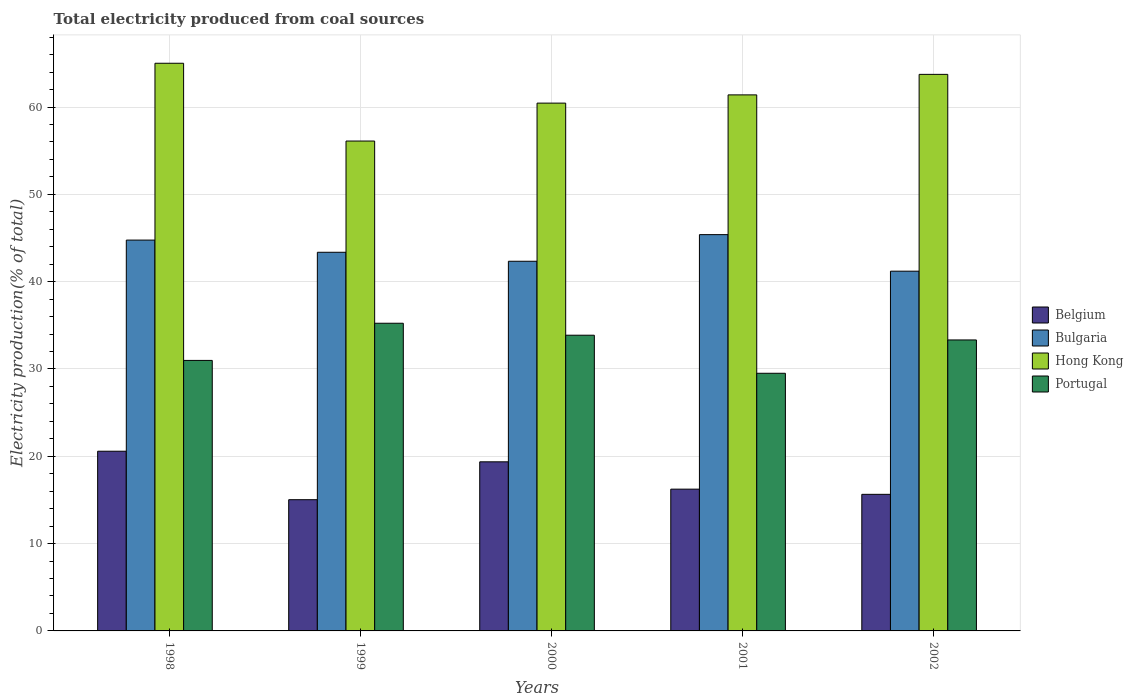How many different coloured bars are there?
Make the answer very short. 4. Are the number of bars per tick equal to the number of legend labels?
Offer a terse response. Yes. Are the number of bars on each tick of the X-axis equal?
Offer a very short reply. Yes. How many bars are there on the 4th tick from the left?
Your response must be concise. 4. In how many cases, is the number of bars for a given year not equal to the number of legend labels?
Keep it short and to the point. 0. What is the total electricity produced in Hong Kong in 1999?
Your answer should be compact. 56.1. Across all years, what is the maximum total electricity produced in Bulgaria?
Keep it short and to the point. 45.38. Across all years, what is the minimum total electricity produced in Portugal?
Offer a very short reply. 29.51. In which year was the total electricity produced in Portugal minimum?
Give a very brief answer. 2001. What is the total total electricity produced in Bulgaria in the graph?
Give a very brief answer. 217.04. What is the difference between the total electricity produced in Portugal in 1999 and that in 2002?
Ensure brevity in your answer.  1.91. What is the difference between the total electricity produced in Belgium in 2000 and the total electricity produced in Hong Kong in 2002?
Your response must be concise. -44.37. What is the average total electricity produced in Portugal per year?
Ensure brevity in your answer.  32.58. In the year 2002, what is the difference between the total electricity produced in Portugal and total electricity produced in Bulgaria?
Ensure brevity in your answer.  -7.88. In how many years, is the total electricity produced in Portugal greater than 10 %?
Offer a very short reply. 5. What is the ratio of the total electricity produced in Belgium in 2000 to that in 2001?
Your answer should be compact. 1.19. Is the difference between the total electricity produced in Portugal in 1998 and 2002 greater than the difference between the total electricity produced in Bulgaria in 1998 and 2002?
Provide a succinct answer. No. What is the difference between the highest and the second highest total electricity produced in Bulgaria?
Your answer should be very brief. 0.62. What is the difference between the highest and the lowest total electricity produced in Belgium?
Your answer should be very brief. 5.55. In how many years, is the total electricity produced in Portugal greater than the average total electricity produced in Portugal taken over all years?
Your answer should be compact. 3. Is the sum of the total electricity produced in Hong Kong in 1998 and 2000 greater than the maximum total electricity produced in Bulgaria across all years?
Your answer should be compact. Yes. What does the 1st bar from the left in 1999 represents?
Your answer should be compact. Belgium. What does the 1st bar from the right in 2002 represents?
Offer a terse response. Portugal. How many years are there in the graph?
Offer a very short reply. 5. What is the difference between two consecutive major ticks on the Y-axis?
Offer a terse response. 10. Are the values on the major ticks of Y-axis written in scientific E-notation?
Provide a succinct answer. No. Does the graph contain any zero values?
Ensure brevity in your answer.  No. What is the title of the graph?
Keep it short and to the point. Total electricity produced from coal sources. What is the label or title of the X-axis?
Make the answer very short. Years. What is the label or title of the Y-axis?
Offer a terse response. Electricity production(% of total). What is the Electricity production(% of total) of Belgium in 1998?
Give a very brief answer. 20.58. What is the Electricity production(% of total) in Bulgaria in 1998?
Offer a very short reply. 44.76. What is the Electricity production(% of total) in Hong Kong in 1998?
Offer a terse response. 65.01. What is the Electricity production(% of total) in Portugal in 1998?
Give a very brief answer. 30.98. What is the Electricity production(% of total) in Belgium in 1999?
Ensure brevity in your answer.  15.03. What is the Electricity production(% of total) of Bulgaria in 1999?
Offer a very short reply. 43.36. What is the Electricity production(% of total) of Hong Kong in 1999?
Provide a succinct answer. 56.1. What is the Electricity production(% of total) in Portugal in 1999?
Give a very brief answer. 35.24. What is the Electricity production(% of total) of Belgium in 2000?
Make the answer very short. 19.37. What is the Electricity production(% of total) of Bulgaria in 2000?
Keep it short and to the point. 42.33. What is the Electricity production(% of total) in Hong Kong in 2000?
Offer a terse response. 60.44. What is the Electricity production(% of total) of Portugal in 2000?
Provide a short and direct response. 33.87. What is the Electricity production(% of total) of Belgium in 2001?
Provide a succinct answer. 16.24. What is the Electricity production(% of total) in Bulgaria in 2001?
Give a very brief answer. 45.38. What is the Electricity production(% of total) in Hong Kong in 2001?
Make the answer very short. 61.39. What is the Electricity production(% of total) of Portugal in 2001?
Keep it short and to the point. 29.51. What is the Electricity production(% of total) in Belgium in 2002?
Offer a very short reply. 15.64. What is the Electricity production(% of total) in Bulgaria in 2002?
Offer a very short reply. 41.2. What is the Electricity production(% of total) of Hong Kong in 2002?
Your answer should be compact. 63.74. What is the Electricity production(% of total) of Portugal in 2002?
Provide a short and direct response. 33.32. Across all years, what is the maximum Electricity production(% of total) of Belgium?
Offer a terse response. 20.58. Across all years, what is the maximum Electricity production(% of total) of Bulgaria?
Provide a short and direct response. 45.38. Across all years, what is the maximum Electricity production(% of total) of Hong Kong?
Make the answer very short. 65.01. Across all years, what is the maximum Electricity production(% of total) in Portugal?
Offer a terse response. 35.24. Across all years, what is the minimum Electricity production(% of total) of Belgium?
Offer a very short reply. 15.03. Across all years, what is the minimum Electricity production(% of total) in Bulgaria?
Provide a succinct answer. 41.2. Across all years, what is the minimum Electricity production(% of total) of Hong Kong?
Provide a short and direct response. 56.1. Across all years, what is the minimum Electricity production(% of total) in Portugal?
Your response must be concise. 29.51. What is the total Electricity production(% of total) of Belgium in the graph?
Provide a short and direct response. 86.85. What is the total Electricity production(% of total) in Bulgaria in the graph?
Your answer should be compact. 217.04. What is the total Electricity production(% of total) in Hong Kong in the graph?
Make the answer very short. 306.68. What is the total Electricity production(% of total) of Portugal in the graph?
Ensure brevity in your answer.  162.91. What is the difference between the Electricity production(% of total) in Belgium in 1998 and that in 1999?
Give a very brief answer. 5.55. What is the difference between the Electricity production(% of total) in Bulgaria in 1998 and that in 1999?
Make the answer very short. 1.4. What is the difference between the Electricity production(% of total) in Hong Kong in 1998 and that in 1999?
Your response must be concise. 8.91. What is the difference between the Electricity production(% of total) in Portugal in 1998 and that in 1999?
Keep it short and to the point. -4.26. What is the difference between the Electricity production(% of total) in Belgium in 1998 and that in 2000?
Your answer should be very brief. 1.21. What is the difference between the Electricity production(% of total) of Bulgaria in 1998 and that in 2000?
Your answer should be compact. 2.42. What is the difference between the Electricity production(% of total) in Hong Kong in 1998 and that in 2000?
Offer a very short reply. 4.56. What is the difference between the Electricity production(% of total) in Portugal in 1998 and that in 2000?
Offer a very short reply. -2.89. What is the difference between the Electricity production(% of total) of Belgium in 1998 and that in 2001?
Offer a terse response. 4.34. What is the difference between the Electricity production(% of total) of Bulgaria in 1998 and that in 2001?
Your response must be concise. -0.62. What is the difference between the Electricity production(% of total) in Hong Kong in 1998 and that in 2001?
Keep it short and to the point. 3.62. What is the difference between the Electricity production(% of total) in Portugal in 1998 and that in 2001?
Offer a very short reply. 1.47. What is the difference between the Electricity production(% of total) of Belgium in 1998 and that in 2002?
Keep it short and to the point. 4.94. What is the difference between the Electricity production(% of total) of Bulgaria in 1998 and that in 2002?
Your answer should be compact. 3.56. What is the difference between the Electricity production(% of total) of Hong Kong in 1998 and that in 2002?
Your answer should be very brief. 1.27. What is the difference between the Electricity production(% of total) of Portugal in 1998 and that in 2002?
Keep it short and to the point. -2.34. What is the difference between the Electricity production(% of total) in Belgium in 1999 and that in 2000?
Keep it short and to the point. -4.34. What is the difference between the Electricity production(% of total) in Bulgaria in 1999 and that in 2000?
Provide a succinct answer. 1.03. What is the difference between the Electricity production(% of total) in Hong Kong in 1999 and that in 2000?
Your answer should be compact. -4.34. What is the difference between the Electricity production(% of total) of Portugal in 1999 and that in 2000?
Ensure brevity in your answer.  1.37. What is the difference between the Electricity production(% of total) in Belgium in 1999 and that in 2001?
Offer a terse response. -1.21. What is the difference between the Electricity production(% of total) in Bulgaria in 1999 and that in 2001?
Offer a very short reply. -2.02. What is the difference between the Electricity production(% of total) of Hong Kong in 1999 and that in 2001?
Offer a very short reply. -5.28. What is the difference between the Electricity production(% of total) of Portugal in 1999 and that in 2001?
Provide a short and direct response. 5.73. What is the difference between the Electricity production(% of total) in Belgium in 1999 and that in 2002?
Keep it short and to the point. -0.61. What is the difference between the Electricity production(% of total) in Bulgaria in 1999 and that in 2002?
Your answer should be very brief. 2.16. What is the difference between the Electricity production(% of total) in Hong Kong in 1999 and that in 2002?
Provide a succinct answer. -7.64. What is the difference between the Electricity production(% of total) in Portugal in 1999 and that in 2002?
Keep it short and to the point. 1.91. What is the difference between the Electricity production(% of total) in Belgium in 2000 and that in 2001?
Provide a short and direct response. 3.13. What is the difference between the Electricity production(% of total) of Bulgaria in 2000 and that in 2001?
Ensure brevity in your answer.  -3.05. What is the difference between the Electricity production(% of total) of Hong Kong in 2000 and that in 2001?
Provide a short and direct response. -0.94. What is the difference between the Electricity production(% of total) in Portugal in 2000 and that in 2001?
Keep it short and to the point. 4.36. What is the difference between the Electricity production(% of total) of Belgium in 2000 and that in 2002?
Make the answer very short. 3.72. What is the difference between the Electricity production(% of total) in Bulgaria in 2000 and that in 2002?
Make the answer very short. 1.14. What is the difference between the Electricity production(% of total) in Hong Kong in 2000 and that in 2002?
Your answer should be compact. -3.29. What is the difference between the Electricity production(% of total) of Portugal in 2000 and that in 2002?
Ensure brevity in your answer.  0.54. What is the difference between the Electricity production(% of total) of Belgium in 2001 and that in 2002?
Give a very brief answer. 0.59. What is the difference between the Electricity production(% of total) of Bulgaria in 2001 and that in 2002?
Provide a short and direct response. 4.18. What is the difference between the Electricity production(% of total) in Hong Kong in 2001 and that in 2002?
Your answer should be compact. -2.35. What is the difference between the Electricity production(% of total) of Portugal in 2001 and that in 2002?
Offer a very short reply. -3.82. What is the difference between the Electricity production(% of total) of Belgium in 1998 and the Electricity production(% of total) of Bulgaria in 1999?
Ensure brevity in your answer.  -22.78. What is the difference between the Electricity production(% of total) of Belgium in 1998 and the Electricity production(% of total) of Hong Kong in 1999?
Offer a terse response. -35.52. What is the difference between the Electricity production(% of total) of Belgium in 1998 and the Electricity production(% of total) of Portugal in 1999?
Keep it short and to the point. -14.66. What is the difference between the Electricity production(% of total) in Bulgaria in 1998 and the Electricity production(% of total) in Hong Kong in 1999?
Make the answer very short. -11.34. What is the difference between the Electricity production(% of total) of Bulgaria in 1998 and the Electricity production(% of total) of Portugal in 1999?
Provide a short and direct response. 9.52. What is the difference between the Electricity production(% of total) in Hong Kong in 1998 and the Electricity production(% of total) in Portugal in 1999?
Offer a terse response. 29.77. What is the difference between the Electricity production(% of total) in Belgium in 1998 and the Electricity production(% of total) in Bulgaria in 2000?
Your answer should be very brief. -21.76. What is the difference between the Electricity production(% of total) of Belgium in 1998 and the Electricity production(% of total) of Hong Kong in 2000?
Provide a succinct answer. -39.87. What is the difference between the Electricity production(% of total) in Belgium in 1998 and the Electricity production(% of total) in Portugal in 2000?
Offer a very short reply. -13.29. What is the difference between the Electricity production(% of total) in Bulgaria in 1998 and the Electricity production(% of total) in Hong Kong in 2000?
Make the answer very short. -15.69. What is the difference between the Electricity production(% of total) of Bulgaria in 1998 and the Electricity production(% of total) of Portugal in 2000?
Your response must be concise. 10.89. What is the difference between the Electricity production(% of total) of Hong Kong in 1998 and the Electricity production(% of total) of Portugal in 2000?
Offer a very short reply. 31.14. What is the difference between the Electricity production(% of total) of Belgium in 1998 and the Electricity production(% of total) of Bulgaria in 2001?
Give a very brief answer. -24.8. What is the difference between the Electricity production(% of total) in Belgium in 1998 and the Electricity production(% of total) in Hong Kong in 2001?
Give a very brief answer. -40.81. What is the difference between the Electricity production(% of total) of Belgium in 1998 and the Electricity production(% of total) of Portugal in 2001?
Offer a terse response. -8.93. What is the difference between the Electricity production(% of total) of Bulgaria in 1998 and the Electricity production(% of total) of Hong Kong in 2001?
Your answer should be compact. -16.63. What is the difference between the Electricity production(% of total) of Bulgaria in 1998 and the Electricity production(% of total) of Portugal in 2001?
Keep it short and to the point. 15.25. What is the difference between the Electricity production(% of total) in Hong Kong in 1998 and the Electricity production(% of total) in Portugal in 2001?
Ensure brevity in your answer.  35.5. What is the difference between the Electricity production(% of total) in Belgium in 1998 and the Electricity production(% of total) in Bulgaria in 2002?
Provide a short and direct response. -20.62. What is the difference between the Electricity production(% of total) of Belgium in 1998 and the Electricity production(% of total) of Hong Kong in 2002?
Your answer should be very brief. -43.16. What is the difference between the Electricity production(% of total) in Belgium in 1998 and the Electricity production(% of total) in Portugal in 2002?
Make the answer very short. -12.74. What is the difference between the Electricity production(% of total) in Bulgaria in 1998 and the Electricity production(% of total) in Hong Kong in 2002?
Offer a very short reply. -18.98. What is the difference between the Electricity production(% of total) of Bulgaria in 1998 and the Electricity production(% of total) of Portugal in 2002?
Provide a short and direct response. 11.44. What is the difference between the Electricity production(% of total) in Hong Kong in 1998 and the Electricity production(% of total) in Portugal in 2002?
Give a very brief answer. 31.69. What is the difference between the Electricity production(% of total) of Belgium in 1999 and the Electricity production(% of total) of Bulgaria in 2000?
Your answer should be very brief. -27.31. What is the difference between the Electricity production(% of total) in Belgium in 1999 and the Electricity production(% of total) in Hong Kong in 2000?
Provide a short and direct response. -45.42. What is the difference between the Electricity production(% of total) in Belgium in 1999 and the Electricity production(% of total) in Portugal in 2000?
Provide a succinct answer. -18.84. What is the difference between the Electricity production(% of total) in Bulgaria in 1999 and the Electricity production(% of total) in Hong Kong in 2000?
Provide a short and direct response. -17.08. What is the difference between the Electricity production(% of total) in Bulgaria in 1999 and the Electricity production(% of total) in Portugal in 2000?
Provide a succinct answer. 9.5. What is the difference between the Electricity production(% of total) of Hong Kong in 1999 and the Electricity production(% of total) of Portugal in 2000?
Give a very brief answer. 22.24. What is the difference between the Electricity production(% of total) of Belgium in 1999 and the Electricity production(% of total) of Bulgaria in 2001?
Offer a terse response. -30.36. What is the difference between the Electricity production(% of total) of Belgium in 1999 and the Electricity production(% of total) of Hong Kong in 2001?
Your response must be concise. -46.36. What is the difference between the Electricity production(% of total) in Belgium in 1999 and the Electricity production(% of total) in Portugal in 2001?
Make the answer very short. -14.48. What is the difference between the Electricity production(% of total) in Bulgaria in 1999 and the Electricity production(% of total) in Hong Kong in 2001?
Ensure brevity in your answer.  -18.02. What is the difference between the Electricity production(% of total) of Bulgaria in 1999 and the Electricity production(% of total) of Portugal in 2001?
Offer a terse response. 13.86. What is the difference between the Electricity production(% of total) of Hong Kong in 1999 and the Electricity production(% of total) of Portugal in 2001?
Offer a terse response. 26.6. What is the difference between the Electricity production(% of total) of Belgium in 1999 and the Electricity production(% of total) of Bulgaria in 2002?
Offer a terse response. -26.17. What is the difference between the Electricity production(% of total) in Belgium in 1999 and the Electricity production(% of total) in Hong Kong in 2002?
Ensure brevity in your answer.  -48.71. What is the difference between the Electricity production(% of total) of Belgium in 1999 and the Electricity production(% of total) of Portugal in 2002?
Provide a succinct answer. -18.3. What is the difference between the Electricity production(% of total) in Bulgaria in 1999 and the Electricity production(% of total) in Hong Kong in 2002?
Keep it short and to the point. -20.38. What is the difference between the Electricity production(% of total) of Bulgaria in 1999 and the Electricity production(% of total) of Portugal in 2002?
Your answer should be very brief. 10.04. What is the difference between the Electricity production(% of total) in Hong Kong in 1999 and the Electricity production(% of total) in Portugal in 2002?
Keep it short and to the point. 22.78. What is the difference between the Electricity production(% of total) in Belgium in 2000 and the Electricity production(% of total) in Bulgaria in 2001?
Ensure brevity in your answer.  -26.02. What is the difference between the Electricity production(% of total) of Belgium in 2000 and the Electricity production(% of total) of Hong Kong in 2001?
Your response must be concise. -42.02. What is the difference between the Electricity production(% of total) of Belgium in 2000 and the Electricity production(% of total) of Portugal in 2001?
Ensure brevity in your answer.  -10.14. What is the difference between the Electricity production(% of total) in Bulgaria in 2000 and the Electricity production(% of total) in Hong Kong in 2001?
Your answer should be very brief. -19.05. What is the difference between the Electricity production(% of total) of Bulgaria in 2000 and the Electricity production(% of total) of Portugal in 2001?
Offer a terse response. 12.83. What is the difference between the Electricity production(% of total) in Hong Kong in 2000 and the Electricity production(% of total) in Portugal in 2001?
Provide a succinct answer. 30.94. What is the difference between the Electricity production(% of total) of Belgium in 2000 and the Electricity production(% of total) of Bulgaria in 2002?
Provide a succinct answer. -21.83. What is the difference between the Electricity production(% of total) of Belgium in 2000 and the Electricity production(% of total) of Hong Kong in 2002?
Your response must be concise. -44.37. What is the difference between the Electricity production(% of total) in Belgium in 2000 and the Electricity production(% of total) in Portugal in 2002?
Give a very brief answer. -13.96. What is the difference between the Electricity production(% of total) of Bulgaria in 2000 and the Electricity production(% of total) of Hong Kong in 2002?
Give a very brief answer. -21.4. What is the difference between the Electricity production(% of total) in Bulgaria in 2000 and the Electricity production(% of total) in Portugal in 2002?
Offer a terse response. 9.01. What is the difference between the Electricity production(% of total) in Hong Kong in 2000 and the Electricity production(% of total) in Portugal in 2002?
Ensure brevity in your answer.  27.12. What is the difference between the Electricity production(% of total) in Belgium in 2001 and the Electricity production(% of total) in Bulgaria in 2002?
Your answer should be very brief. -24.96. What is the difference between the Electricity production(% of total) in Belgium in 2001 and the Electricity production(% of total) in Hong Kong in 2002?
Ensure brevity in your answer.  -47.5. What is the difference between the Electricity production(% of total) in Belgium in 2001 and the Electricity production(% of total) in Portugal in 2002?
Offer a terse response. -17.09. What is the difference between the Electricity production(% of total) in Bulgaria in 2001 and the Electricity production(% of total) in Hong Kong in 2002?
Offer a terse response. -18.35. What is the difference between the Electricity production(% of total) in Bulgaria in 2001 and the Electricity production(% of total) in Portugal in 2002?
Make the answer very short. 12.06. What is the difference between the Electricity production(% of total) of Hong Kong in 2001 and the Electricity production(% of total) of Portugal in 2002?
Your answer should be very brief. 28.06. What is the average Electricity production(% of total) of Belgium per year?
Give a very brief answer. 17.37. What is the average Electricity production(% of total) in Bulgaria per year?
Provide a succinct answer. 43.41. What is the average Electricity production(% of total) of Hong Kong per year?
Give a very brief answer. 61.34. What is the average Electricity production(% of total) of Portugal per year?
Provide a short and direct response. 32.58. In the year 1998, what is the difference between the Electricity production(% of total) of Belgium and Electricity production(% of total) of Bulgaria?
Offer a terse response. -24.18. In the year 1998, what is the difference between the Electricity production(% of total) in Belgium and Electricity production(% of total) in Hong Kong?
Offer a very short reply. -44.43. In the year 1998, what is the difference between the Electricity production(% of total) in Belgium and Electricity production(% of total) in Portugal?
Your answer should be compact. -10.4. In the year 1998, what is the difference between the Electricity production(% of total) of Bulgaria and Electricity production(% of total) of Hong Kong?
Your response must be concise. -20.25. In the year 1998, what is the difference between the Electricity production(% of total) of Bulgaria and Electricity production(% of total) of Portugal?
Provide a succinct answer. 13.78. In the year 1998, what is the difference between the Electricity production(% of total) in Hong Kong and Electricity production(% of total) in Portugal?
Offer a very short reply. 34.03. In the year 1999, what is the difference between the Electricity production(% of total) in Belgium and Electricity production(% of total) in Bulgaria?
Give a very brief answer. -28.33. In the year 1999, what is the difference between the Electricity production(% of total) of Belgium and Electricity production(% of total) of Hong Kong?
Ensure brevity in your answer.  -41.07. In the year 1999, what is the difference between the Electricity production(% of total) of Belgium and Electricity production(% of total) of Portugal?
Your response must be concise. -20.21. In the year 1999, what is the difference between the Electricity production(% of total) of Bulgaria and Electricity production(% of total) of Hong Kong?
Offer a terse response. -12.74. In the year 1999, what is the difference between the Electricity production(% of total) in Bulgaria and Electricity production(% of total) in Portugal?
Your answer should be very brief. 8.13. In the year 1999, what is the difference between the Electricity production(% of total) of Hong Kong and Electricity production(% of total) of Portugal?
Offer a very short reply. 20.87. In the year 2000, what is the difference between the Electricity production(% of total) of Belgium and Electricity production(% of total) of Bulgaria?
Your answer should be compact. -22.97. In the year 2000, what is the difference between the Electricity production(% of total) of Belgium and Electricity production(% of total) of Hong Kong?
Provide a short and direct response. -41.08. In the year 2000, what is the difference between the Electricity production(% of total) in Belgium and Electricity production(% of total) in Portugal?
Make the answer very short. -14.5. In the year 2000, what is the difference between the Electricity production(% of total) of Bulgaria and Electricity production(% of total) of Hong Kong?
Offer a very short reply. -18.11. In the year 2000, what is the difference between the Electricity production(% of total) in Bulgaria and Electricity production(% of total) in Portugal?
Provide a short and direct response. 8.47. In the year 2000, what is the difference between the Electricity production(% of total) of Hong Kong and Electricity production(% of total) of Portugal?
Your answer should be very brief. 26.58. In the year 2001, what is the difference between the Electricity production(% of total) in Belgium and Electricity production(% of total) in Bulgaria?
Your answer should be compact. -29.15. In the year 2001, what is the difference between the Electricity production(% of total) of Belgium and Electricity production(% of total) of Hong Kong?
Keep it short and to the point. -45.15. In the year 2001, what is the difference between the Electricity production(% of total) of Belgium and Electricity production(% of total) of Portugal?
Make the answer very short. -13.27. In the year 2001, what is the difference between the Electricity production(% of total) of Bulgaria and Electricity production(% of total) of Hong Kong?
Give a very brief answer. -16. In the year 2001, what is the difference between the Electricity production(% of total) of Bulgaria and Electricity production(% of total) of Portugal?
Keep it short and to the point. 15.88. In the year 2001, what is the difference between the Electricity production(% of total) of Hong Kong and Electricity production(% of total) of Portugal?
Your answer should be compact. 31.88. In the year 2002, what is the difference between the Electricity production(% of total) of Belgium and Electricity production(% of total) of Bulgaria?
Offer a very short reply. -25.56. In the year 2002, what is the difference between the Electricity production(% of total) of Belgium and Electricity production(% of total) of Hong Kong?
Offer a terse response. -48.1. In the year 2002, what is the difference between the Electricity production(% of total) in Belgium and Electricity production(% of total) in Portugal?
Your response must be concise. -17.68. In the year 2002, what is the difference between the Electricity production(% of total) in Bulgaria and Electricity production(% of total) in Hong Kong?
Give a very brief answer. -22.54. In the year 2002, what is the difference between the Electricity production(% of total) in Bulgaria and Electricity production(% of total) in Portugal?
Give a very brief answer. 7.88. In the year 2002, what is the difference between the Electricity production(% of total) of Hong Kong and Electricity production(% of total) of Portugal?
Give a very brief answer. 30.41. What is the ratio of the Electricity production(% of total) in Belgium in 1998 to that in 1999?
Your response must be concise. 1.37. What is the ratio of the Electricity production(% of total) of Bulgaria in 1998 to that in 1999?
Offer a very short reply. 1.03. What is the ratio of the Electricity production(% of total) of Hong Kong in 1998 to that in 1999?
Give a very brief answer. 1.16. What is the ratio of the Electricity production(% of total) of Portugal in 1998 to that in 1999?
Your answer should be compact. 0.88. What is the ratio of the Electricity production(% of total) in Belgium in 1998 to that in 2000?
Ensure brevity in your answer.  1.06. What is the ratio of the Electricity production(% of total) of Bulgaria in 1998 to that in 2000?
Your answer should be compact. 1.06. What is the ratio of the Electricity production(% of total) of Hong Kong in 1998 to that in 2000?
Ensure brevity in your answer.  1.08. What is the ratio of the Electricity production(% of total) in Portugal in 1998 to that in 2000?
Your answer should be compact. 0.91. What is the ratio of the Electricity production(% of total) of Belgium in 1998 to that in 2001?
Your answer should be very brief. 1.27. What is the ratio of the Electricity production(% of total) in Bulgaria in 1998 to that in 2001?
Provide a succinct answer. 0.99. What is the ratio of the Electricity production(% of total) of Hong Kong in 1998 to that in 2001?
Keep it short and to the point. 1.06. What is the ratio of the Electricity production(% of total) of Belgium in 1998 to that in 2002?
Keep it short and to the point. 1.32. What is the ratio of the Electricity production(% of total) in Bulgaria in 1998 to that in 2002?
Offer a terse response. 1.09. What is the ratio of the Electricity production(% of total) in Hong Kong in 1998 to that in 2002?
Offer a very short reply. 1.02. What is the ratio of the Electricity production(% of total) of Portugal in 1998 to that in 2002?
Give a very brief answer. 0.93. What is the ratio of the Electricity production(% of total) in Belgium in 1999 to that in 2000?
Your response must be concise. 0.78. What is the ratio of the Electricity production(% of total) of Bulgaria in 1999 to that in 2000?
Your response must be concise. 1.02. What is the ratio of the Electricity production(% of total) in Hong Kong in 1999 to that in 2000?
Offer a terse response. 0.93. What is the ratio of the Electricity production(% of total) of Portugal in 1999 to that in 2000?
Offer a terse response. 1.04. What is the ratio of the Electricity production(% of total) in Belgium in 1999 to that in 2001?
Ensure brevity in your answer.  0.93. What is the ratio of the Electricity production(% of total) in Bulgaria in 1999 to that in 2001?
Your answer should be compact. 0.96. What is the ratio of the Electricity production(% of total) of Hong Kong in 1999 to that in 2001?
Your response must be concise. 0.91. What is the ratio of the Electricity production(% of total) of Portugal in 1999 to that in 2001?
Give a very brief answer. 1.19. What is the ratio of the Electricity production(% of total) of Belgium in 1999 to that in 2002?
Ensure brevity in your answer.  0.96. What is the ratio of the Electricity production(% of total) of Bulgaria in 1999 to that in 2002?
Offer a very short reply. 1.05. What is the ratio of the Electricity production(% of total) in Hong Kong in 1999 to that in 2002?
Your answer should be very brief. 0.88. What is the ratio of the Electricity production(% of total) of Portugal in 1999 to that in 2002?
Offer a terse response. 1.06. What is the ratio of the Electricity production(% of total) of Belgium in 2000 to that in 2001?
Keep it short and to the point. 1.19. What is the ratio of the Electricity production(% of total) in Bulgaria in 2000 to that in 2001?
Give a very brief answer. 0.93. What is the ratio of the Electricity production(% of total) of Hong Kong in 2000 to that in 2001?
Your response must be concise. 0.98. What is the ratio of the Electricity production(% of total) of Portugal in 2000 to that in 2001?
Ensure brevity in your answer.  1.15. What is the ratio of the Electricity production(% of total) of Belgium in 2000 to that in 2002?
Offer a terse response. 1.24. What is the ratio of the Electricity production(% of total) in Bulgaria in 2000 to that in 2002?
Provide a succinct answer. 1.03. What is the ratio of the Electricity production(% of total) of Hong Kong in 2000 to that in 2002?
Offer a very short reply. 0.95. What is the ratio of the Electricity production(% of total) in Portugal in 2000 to that in 2002?
Ensure brevity in your answer.  1.02. What is the ratio of the Electricity production(% of total) of Belgium in 2001 to that in 2002?
Offer a very short reply. 1.04. What is the ratio of the Electricity production(% of total) in Bulgaria in 2001 to that in 2002?
Your response must be concise. 1.1. What is the ratio of the Electricity production(% of total) in Hong Kong in 2001 to that in 2002?
Your answer should be compact. 0.96. What is the ratio of the Electricity production(% of total) in Portugal in 2001 to that in 2002?
Give a very brief answer. 0.89. What is the difference between the highest and the second highest Electricity production(% of total) of Belgium?
Offer a very short reply. 1.21. What is the difference between the highest and the second highest Electricity production(% of total) in Bulgaria?
Offer a terse response. 0.62. What is the difference between the highest and the second highest Electricity production(% of total) in Hong Kong?
Your response must be concise. 1.27. What is the difference between the highest and the second highest Electricity production(% of total) in Portugal?
Your response must be concise. 1.37. What is the difference between the highest and the lowest Electricity production(% of total) in Belgium?
Provide a short and direct response. 5.55. What is the difference between the highest and the lowest Electricity production(% of total) in Bulgaria?
Ensure brevity in your answer.  4.18. What is the difference between the highest and the lowest Electricity production(% of total) in Hong Kong?
Give a very brief answer. 8.91. What is the difference between the highest and the lowest Electricity production(% of total) of Portugal?
Your answer should be compact. 5.73. 